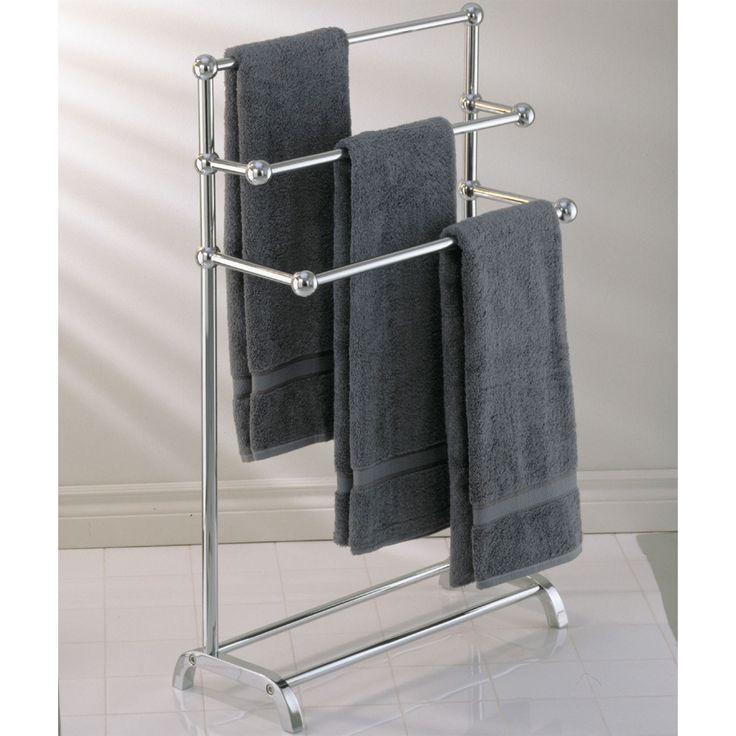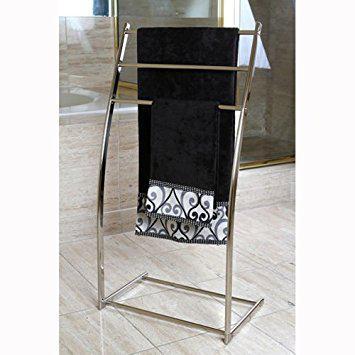The first image is the image on the left, the second image is the image on the right. Considering the images on both sides, is "dark colored towels are layers in 3's on a chrome stand" valid? Answer yes or no. Yes. The first image is the image on the left, the second image is the image on the right. Evaluate the accuracy of this statement regarding the images: "One set of towels is plain, and the other has a pattern on at least a portion of it.". Is it true? Answer yes or no. Yes. 